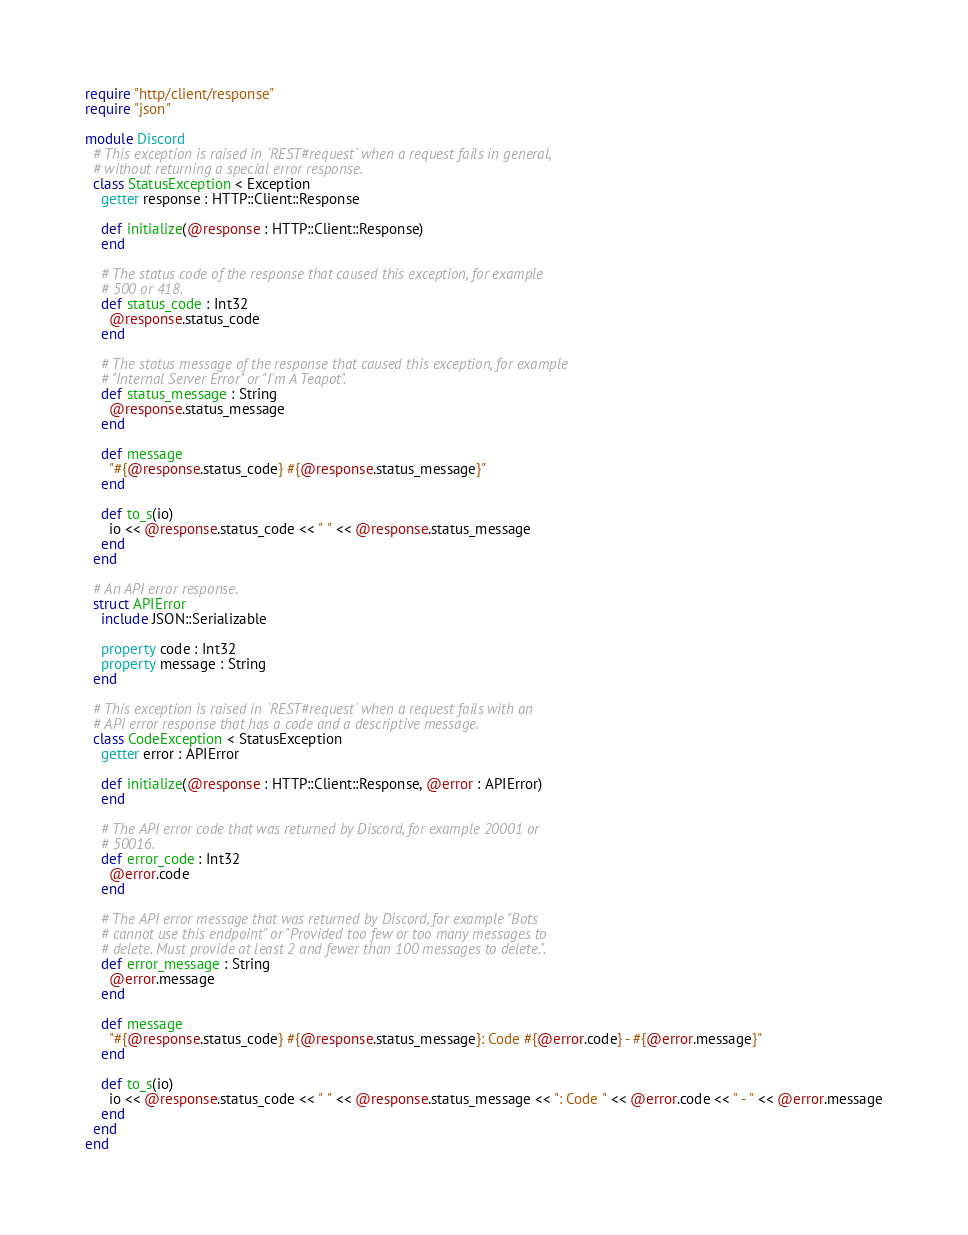Convert code to text. <code><loc_0><loc_0><loc_500><loc_500><_Crystal_>require "http/client/response"
require "json"

module Discord
  # This exception is raised in `REST#request` when a request fails in general,
  # without returning a special error response.
  class StatusException < Exception
    getter response : HTTP::Client::Response

    def initialize(@response : HTTP::Client::Response)
    end

    # The status code of the response that caused this exception, for example
    # 500 or 418.
    def status_code : Int32
      @response.status_code
    end

    # The status message of the response that caused this exception, for example
    # "Internal Server Error" or "I'm A Teapot".
    def status_message : String
      @response.status_message
    end

    def message
      "#{@response.status_code} #{@response.status_message}"
    end

    def to_s(io)
      io << @response.status_code << " " << @response.status_message
    end
  end

  # An API error response.
  struct APIError
    include JSON::Serializable

    property code : Int32
    property message : String
  end

  # This exception is raised in `REST#request` when a request fails with an
  # API error response that has a code and a descriptive message.
  class CodeException < StatusException
    getter error : APIError

    def initialize(@response : HTTP::Client::Response, @error : APIError)
    end

    # The API error code that was returned by Discord, for example 20001 or
    # 50016.
    def error_code : Int32
      @error.code
    end

    # The API error message that was returned by Discord, for example "Bots
    # cannot use this endpoint" or "Provided too few or too many messages to
    # delete. Must provide at least 2 and fewer than 100 messages to delete.".
    def error_message : String
      @error.message
    end

    def message
      "#{@response.status_code} #{@response.status_message}: Code #{@error.code} - #{@error.message}"
    end

    def to_s(io)
      io << @response.status_code << " " << @response.status_message << ": Code " << @error.code << " - " << @error.message
    end
  end
end
</code> 